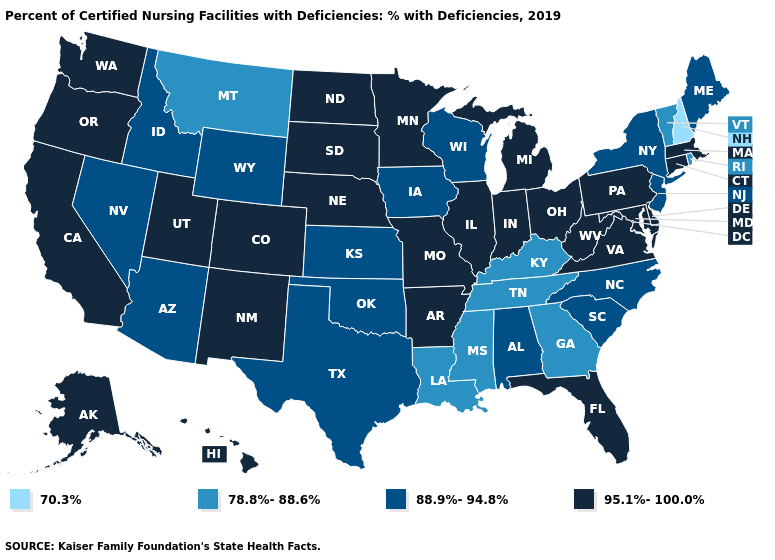Does Arkansas have the highest value in the USA?
Write a very short answer. Yes. Does the map have missing data?
Short answer required. No. Name the states that have a value in the range 95.1%-100.0%?
Concise answer only. Alaska, Arkansas, California, Colorado, Connecticut, Delaware, Florida, Hawaii, Illinois, Indiana, Maryland, Massachusetts, Michigan, Minnesota, Missouri, Nebraska, New Mexico, North Dakota, Ohio, Oregon, Pennsylvania, South Dakota, Utah, Virginia, Washington, West Virginia. Does Missouri have the same value as Idaho?
Quick response, please. No. Name the states that have a value in the range 88.9%-94.8%?
Quick response, please. Alabama, Arizona, Idaho, Iowa, Kansas, Maine, Nevada, New Jersey, New York, North Carolina, Oklahoma, South Carolina, Texas, Wisconsin, Wyoming. Name the states that have a value in the range 95.1%-100.0%?
Keep it brief. Alaska, Arkansas, California, Colorado, Connecticut, Delaware, Florida, Hawaii, Illinois, Indiana, Maryland, Massachusetts, Michigan, Minnesota, Missouri, Nebraska, New Mexico, North Dakota, Ohio, Oregon, Pennsylvania, South Dakota, Utah, Virginia, Washington, West Virginia. Which states have the lowest value in the USA?
Keep it brief. New Hampshire. Name the states that have a value in the range 88.9%-94.8%?
Answer briefly. Alabama, Arizona, Idaho, Iowa, Kansas, Maine, Nevada, New Jersey, New York, North Carolina, Oklahoma, South Carolina, Texas, Wisconsin, Wyoming. Name the states that have a value in the range 95.1%-100.0%?
Be succinct. Alaska, Arkansas, California, Colorado, Connecticut, Delaware, Florida, Hawaii, Illinois, Indiana, Maryland, Massachusetts, Michigan, Minnesota, Missouri, Nebraska, New Mexico, North Dakota, Ohio, Oregon, Pennsylvania, South Dakota, Utah, Virginia, Washington, West Virginia. What is the value of California?
Be succinct. 95.1%-100.0%. How many symbols are there in the legend?
Write a very short answer. 4. What is the value of Idaho?
Answer briefly. 88.9%-94.8%. What is the value of Nebraska?
Write a very short answer. 95.1%-100.0%. Which states have the lowest value in the USA?
Be succinct. New Hampshire. 